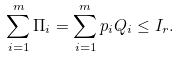Convert formula to latex. <formula><loc_0><loc_0><loc_500><loc_500>\sum _ { i = 1 } ^ { m } \Pi _ { i } = \sum _ { i = 1 } ^ { m } p _ { i } Q _ { i } \leq I _ { r } .</formula> 